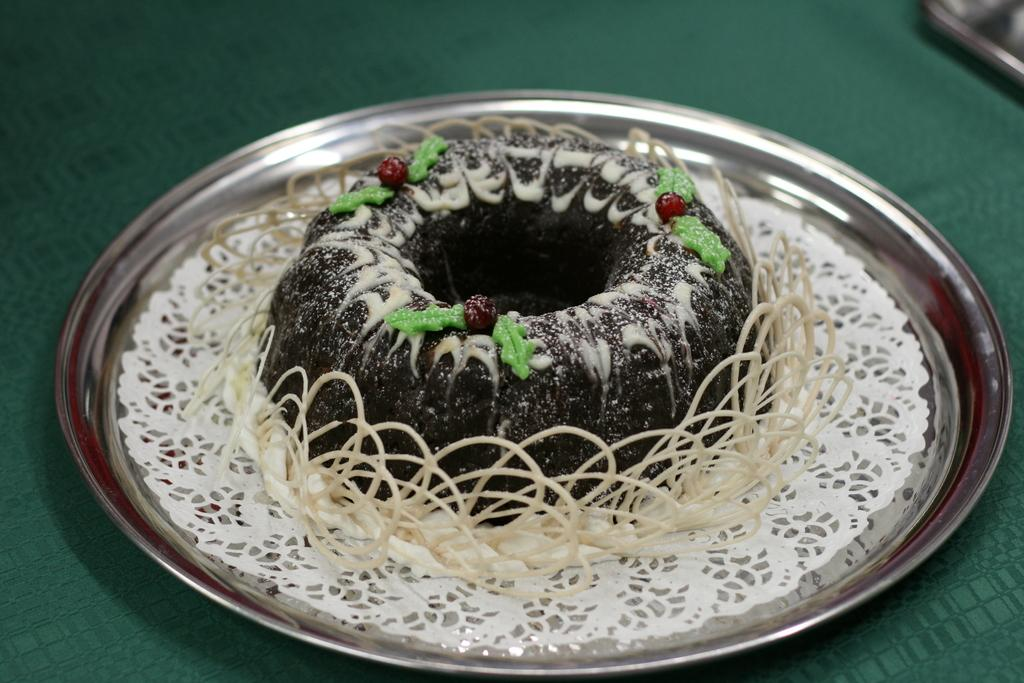What type of furniture is present in the image? There is a table in the image. What is placed on the table? There is a plate on the table. What is on the plate? There is a cake on the plate. Can you describe the top part of the image? The top part of the image is blurred. What type of toothbrush is used to decorate the cake in the image? There is no toothbrush present on the cake or in the image. 